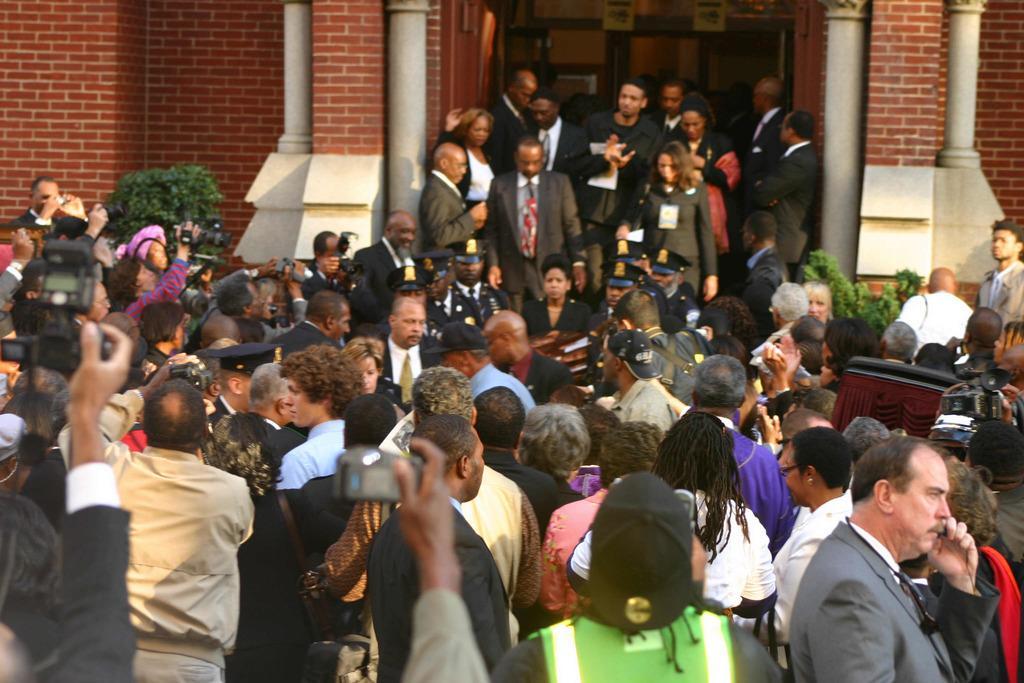Please provide a concise description of this image. In the image there are many people in suits standing, in the back there is a building with plants on either side and few people standing on the steps at the entrance, in the front there are few people taking pictures in the camera. 